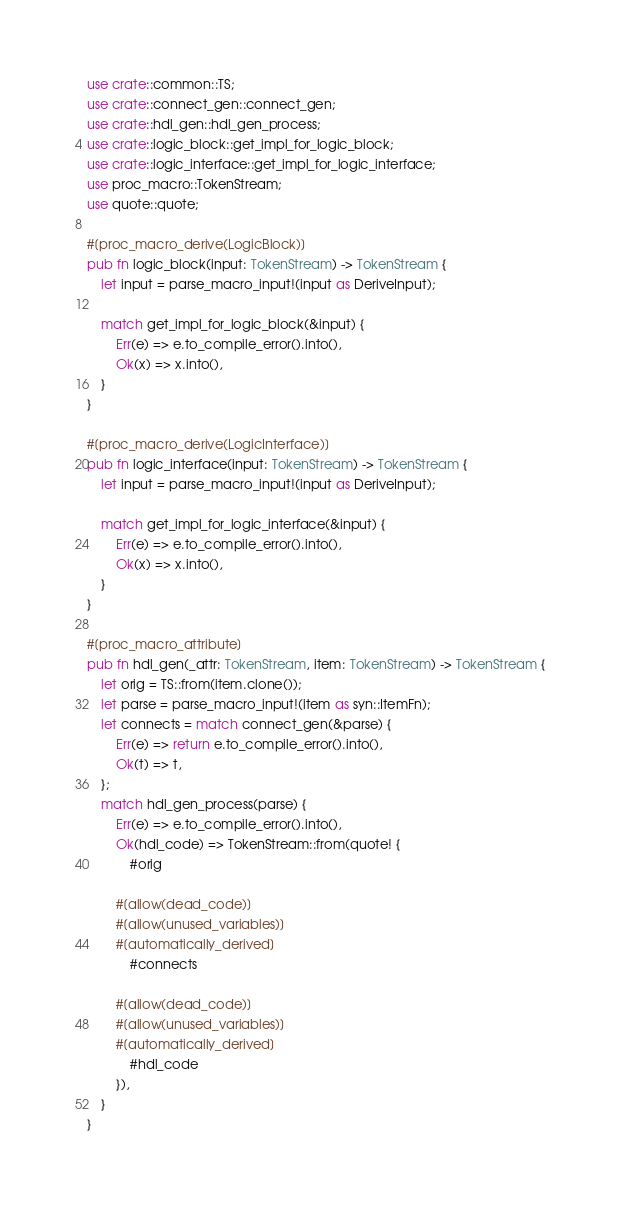Convert code to text. <code><loc_0><loc_0><loc_500><loc_500><_Rust_>
use crate::common::TS;
use crate::connect_gen::connect_gen;
use crate::hdl_gen::hdl_gen_process;
use crate::logic_block::get_impl_for_logic_block;
use crate::logic_interface::get_impl_for_logic_interface;
use proc_macro::TokenStream;
use quote::quote;

#[proc_macro_derive(LogicBlock)]
pub fn logic_block(input: TokenStream) -> TokenStream {
    let input = parse_macro_input!(input as DeriveInput);

    match get_impl_for_logic_block(&input) {
        Err(e) => e.to_compile_error().into(),
        Ok(x) => x.into(),
    }
}

#[proc_macro_derive(LogicInterface)]
pub fn logic_interface(input: TokenStream) -> TokenStream {
    let input = parse_macro_input!(input as DeriveInput);

    match get_impl_for_logic_interface(&input) {
        Err(e) => e.to_compile_error().into(),
        Ok(x) => x.into(),
    }
}

#[proc_macro_attribute]
pub fn hdl_gen(_attr: TokenStream, item: TokenStream) -> TokenStream {
    let orig = TS::from(item.clone());
    let parse = parse_macro_input!(item as syn::ItemFn);
    let connects = match connect_gen(&parse) {
        Err(e) => return e.to_compile_error().into(),
        Ok(t) => t,
    };
    match hdl_gen_process(parse) {
        Err(e) => e.to_compile_error().into(),
        Ok(hdl_code) => TokenStream::from(quote! {
            #orig

        #[allow(dead_code)]
        #[allow(unused_variables)]
        #[automatically_derived]
            #connects

        #[allow(dead_code)]
        #[allow(unused_variables)]
        #[automatically_derived]
            #hdl_code
        }),
    }
}
</code> 